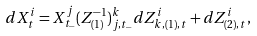Convert formula to latex. <formula><loc_0><loc_0><loc_500><loc_500>d X ^ { i } _ { t } = X ^ { j } _ { t _ { - } } ( Z ^ { - 1 } _ { ( 1 ) } ) ^ { k } _ { j , t _ { - } } { d Z ^ { i } _ { k , ( 1 ) , t } + d Z ^ { i } _ { ( 2 ) , t } } ,</formula> 